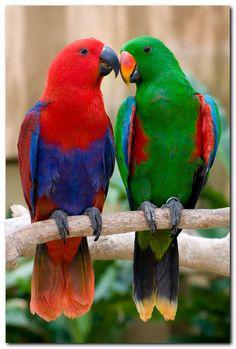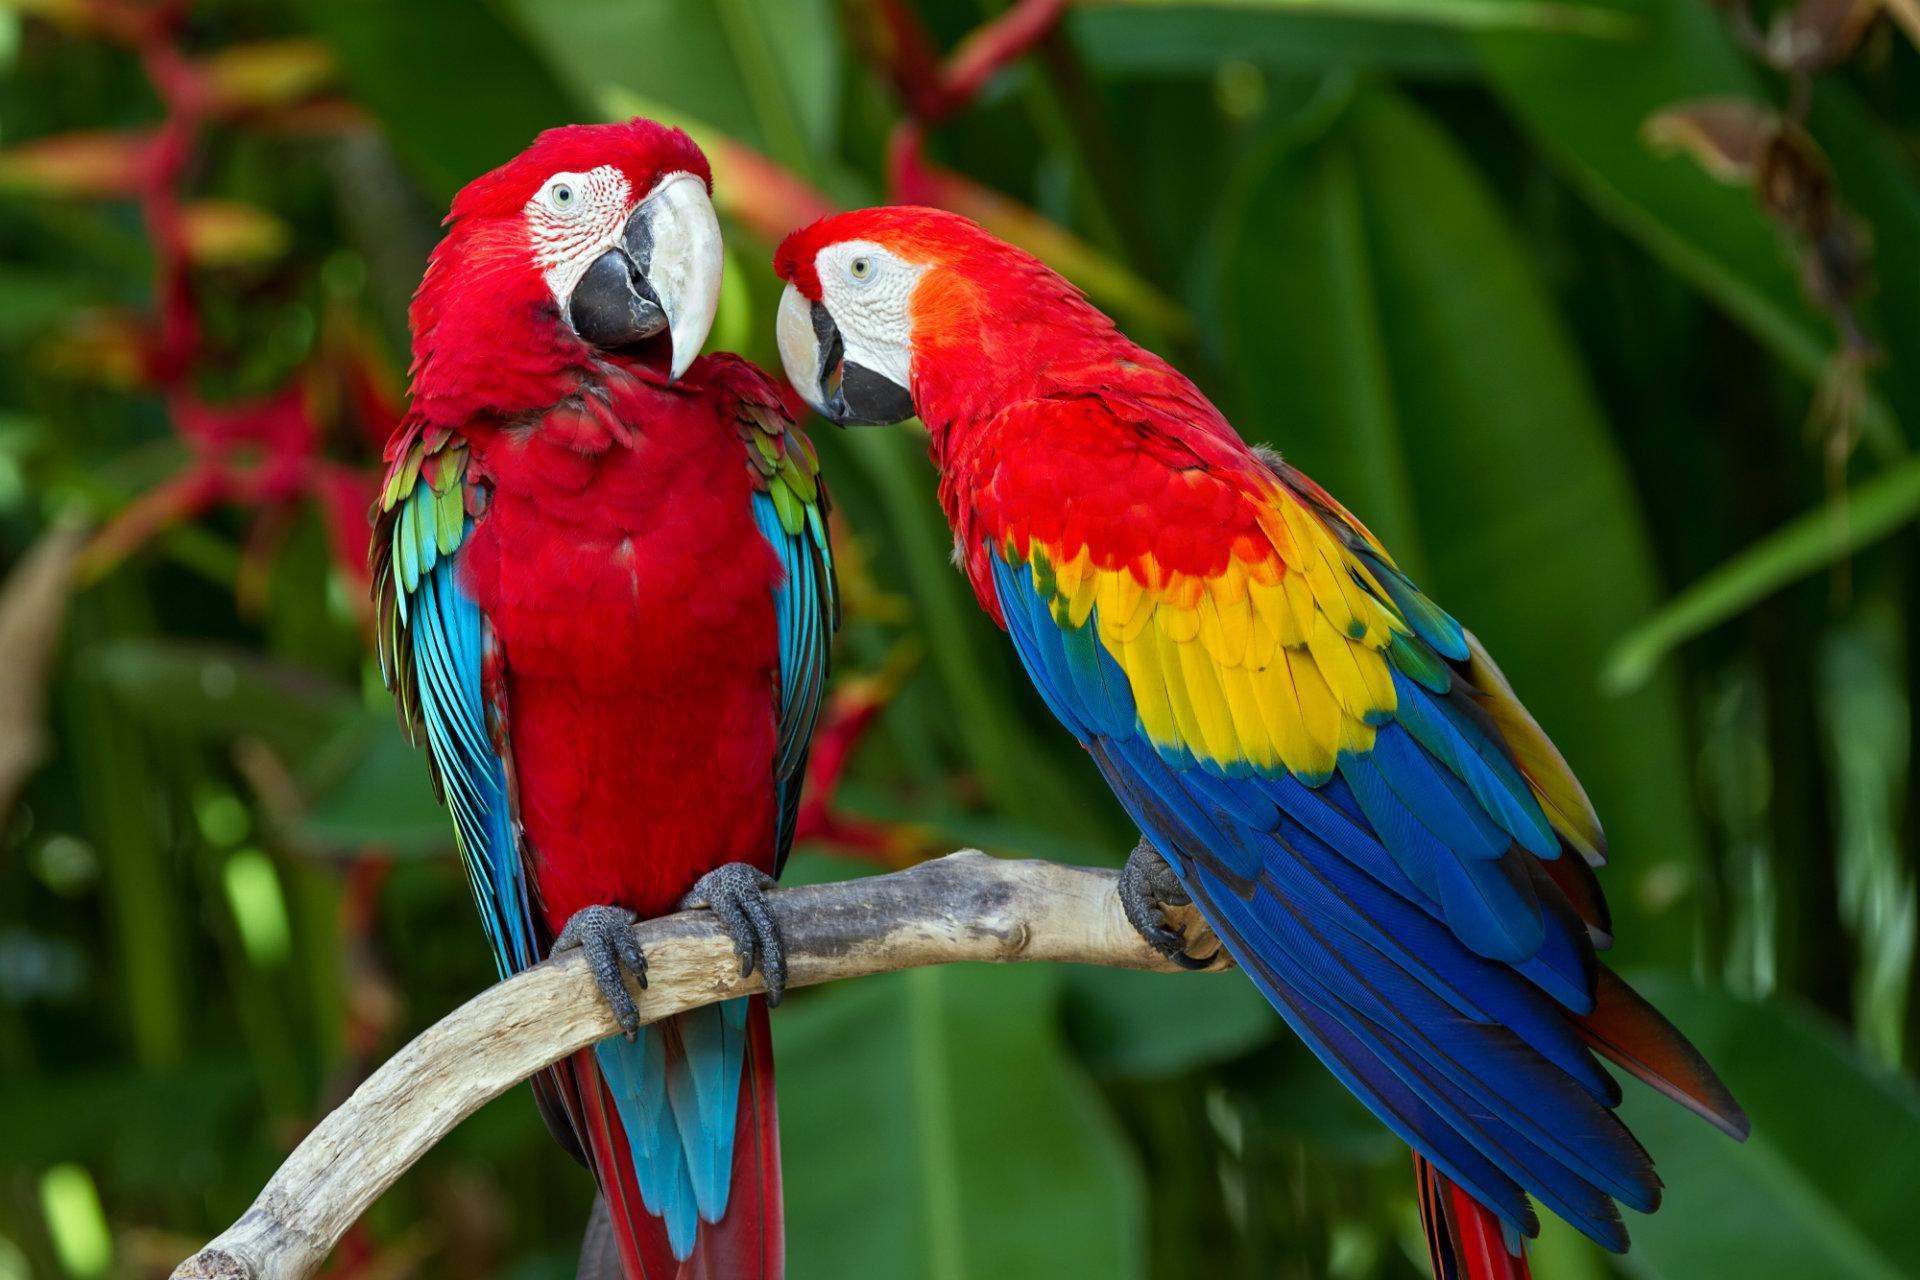The first image is the image on the left, the second image is the image on the right. For the images displayed, is the sentence "A blue bird is touching another blue bird." factually correct? Answer yes or no. No. The first image is the image on the left, the second image is the image on the right. Evaluate the accuracy of this statement regarding the images: "One of the images has two matching solid colored birds standing next to each other on the same branch.". Is it true? Answer yes or no. No. 